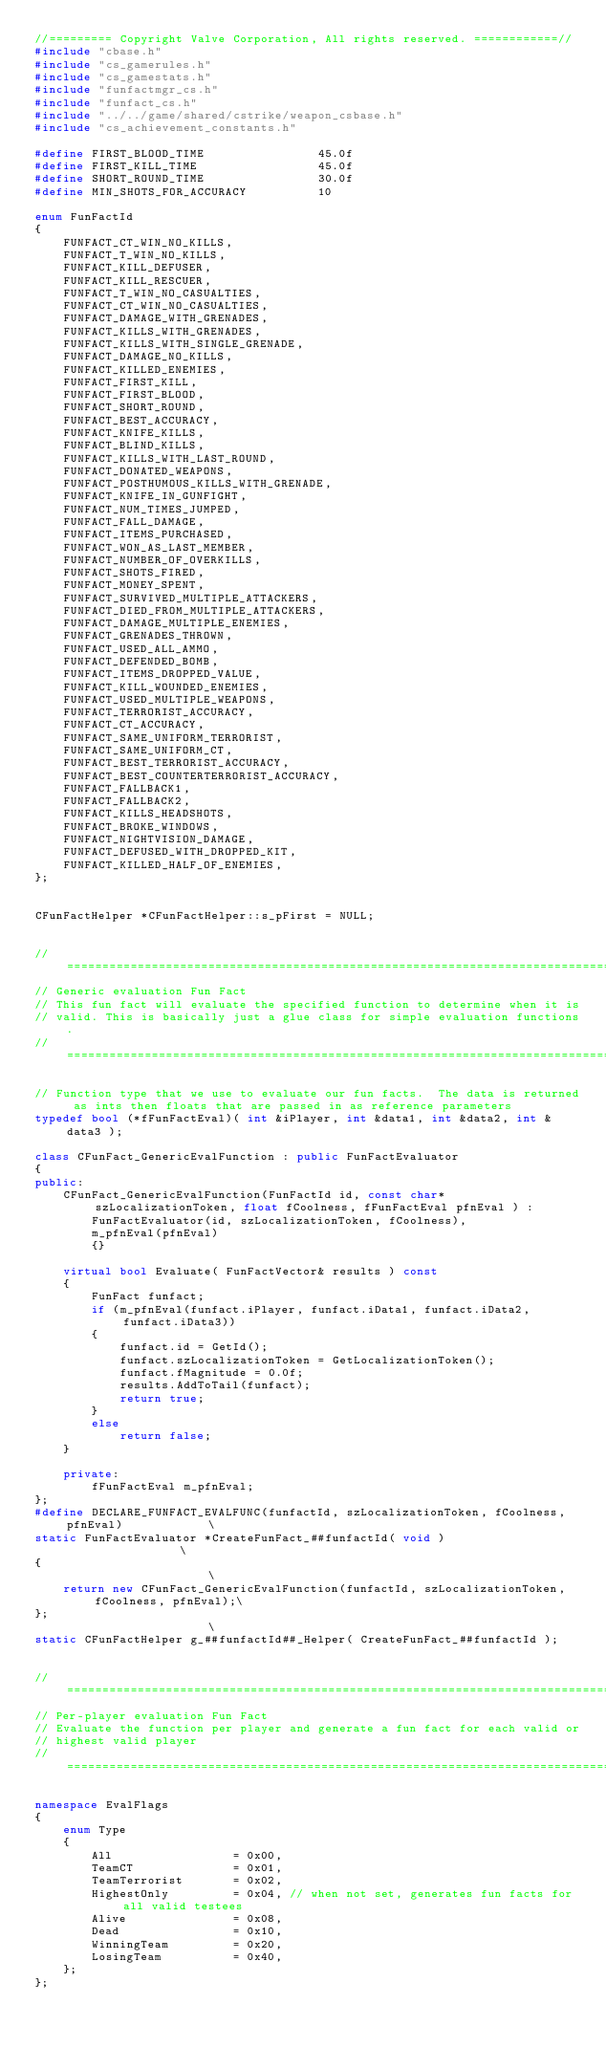Convert code to text. <code><loc_0><loc_0><loc_500><loc_500><_C++_>//========= Copyright Valve Corporation, All rights reserved. ============//
#include "cbase.h"
#include "cs_gamerules.h"
#include "cs_gamestats.h"
#include "funfactmgr_cs.h"
#include "funfact_cs.h"
#include "../../game/shared/cstrike/weapon_csbase.h"
#include "cs_achievement_constants.h"

#define FIRST_BLOOD_TIME				45.0f
#define FIRST_KILL_TIME					45.0f
#define SHORT_ROUND_TIME				30.0f
#define MIN_SHOTS_FOR_ACCURACY			10

enum FunFactId
{
	FUNFACT_CT_WIN_NO_KILLS,
	FUNFACT_T_WIN_NO_KILLS,
	FUNFACT_KILL_DEFUSER,
	FUNFACT_KILL_RESCUER,
	FUNFACT_T_WIN_NO_CASUALTIES,
	FUNFACT_CT_WIN_NO_CASUALTIES,
	FUNFACT_DAMAGE_WITH_GRENADES,
	FUNFACT_KILLS_WITH_GRENADES,
	FUNFACT_KILLS_WITH_SINGLE_GRENADE,
	FUNFACT_DAMAGE_NO_KILLS,
	FUNFACT_KILLED_ENEMIES,
	FUNFACT_FIRST_KILL,
	FUNFACT_FIRST_BLOOD,
	FUNFACT_SHORT_ROUND,
	FUNFACT_BEST_ACCURACY,
	FUNFACT_KNIFE_KILLS,
	FUNFACT_BLIND_KILLS,
	FUNFACT_KILLS_WITH_LAST_ROUND,
	FUNFACT_DONATED_WEAPONS,
	FUNFACT_POSTHUMOUS_KILLS_WITH_GRENADE,    
	FUNFACT_KNIFE_IN_GUNFIGHT,
	FUNFACT_NUM_TIMES_JUMPED,
	FUNFACT_FALL_DAMAGE,
	FUNFACT_ITEMS_PURCHASED,
	FUNFACT_WON_AS_LAST_MEMBER,
	FUNFACT_NUMBER_OF_OVERKILLS,
	FUNFACT_SHOTS_FIRED,
	FUNFACT_MONEY_SPENT,
	FUNFACT_SURVIVED_MULTIPLE_ATTACKERS,
	FUNFACT_DIED_FROM_MULTIPLE_ATTACKERS,
	FUNFACT_DAMAGE_MULTIPLE_ENEMIES,
	FUNFACT_GRENADES_THROWN,
	FUNFACT_USED_ALL_AMMO,
	FUNFACT_DEFENDED_BOMB,
	FUNFACT_ITEMS_DROPPED_VALUE,
	FUNFACT_KILL_WOUNDED_ENEMIES,
	FUNFACT_USED_MULTIPLE_WEAPONS,
	FUNFACT_TERRORIST_ACCURACY,
	FUNFACT_CT_ACCURACY,
	FUNFACT_SAME_UNIFORM_TERRORIST,
	FUNFACT_SAME_UNIFORM_CT,
	FUNFACT_BEST_TERRORIST_ACCURACY,
	FUNFACT_BEST_COUNTERTERRORIST_ACCURACY,
	FUNFACT_FALLBACK1,
	FUNFACT_FALLBACK2,
	FUNFACT_KILLS_HEADSHOTS,
	FUNFACT_BROKE_WINDOWS,
	FUNFACT_NIGHTVISION_DAMAGE,
    FUNFACT_DEFUSED_WITH_DROPPED_KIT,
    FUNFACT_KILLED_HALF_OF_ENEMIES,
};


CFunFactHelper *CFunFactHelper::s_pFirst = NULL;


//=============================================================================
// Generic evaluation Fun Fact
// This fun fact will evaluate the specified function to determine when it is
// valid. This is basically just a glue class for simple evaluation functions.
//=============================================================================

// Function type that we use to evaluate our fun facts.  The data is returned as ints then floats that are passed in as reference parameters
typedef bool (*fFunFactEval)( int &iPlayer, int &data1, int &data2, int &data3 );

class CFunFact_GenericEvalFunction : public FunFactEvaluator
{
public:
	CFunFact_GenericEvalFunction(FunFactId id, const char* szLocalizationToken, float fCoolness, fFunFactEval pfnEval ) :
		FunFactEvaluator(id, szLocalizationToken, fCoolness),
		m_pfnEval(pfnEval)
		{}

	virtual bool Evaluate( FunFactVector& results ) const
	{
		FunFact funfact;
		if (m_pfnEval(funfact.iPlayer, funfact.iData1, funfact.iData2, funfact.iData3))
		{
			funfact.id = GetId();
			funfact.szLocalizationToken = GetLocalizationToken();
			funfact.fMagnitude = 0.0f;
			results.AddToTail(funfact);
			return true;
		}
		else
			return false;
	}

	private:
		fFunFactEval m_pfnEval;
};
#define DECLARE_FUNFACT_EVALFUNC(funfactId, szLocalizationToken, fCoolness, pfnEval)			\
static FunFactEvaluator *CreateFunFact_##funfactId( void )									\
{																								\
	return new CFunFact_GenericEvalFunction(funfactId, szLocalizationToken, fCoolness, pfnEval);\
};																								\
static CFunFactHelper g_##funfactId##_Helper( CreateFunFact_##funfactId );


//=============================================================================
// Per-player evaluation Fun Fact
// Evaluate the function per player and generate a fun fact for each valid or
// highest valid player
//=============================================================================

namespace EvalFlags
{
	enum Type
	{
		All					= 0x00,
		TeamCT				= 0x01,
		TeamTerrorist		= 0x02,
		HighestOnly			= 0x04,	// when not set, generates fun facts for all valid testees
		Alive				= 0x08,
		Dead				= 0x10,
		WinningTeam			= 0x20,
		LosingTeam			= 0x40,
	};
};

</code> 